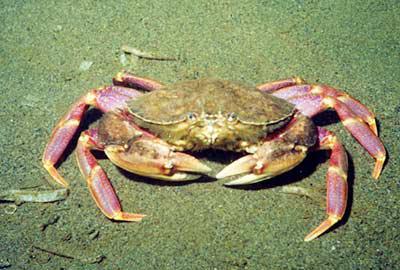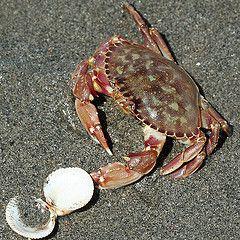The first image is the image on the left, the second image is the image on the right. Analyze the images presented: Is the assertion "Each image is a from-the-top view of one crab, but one image shows a crab with its face and front claws on the top, and one shows them at the bottom." valid? Answer yes or no. No. The first image is the image on the left, the second image is the image on the right. Evaluate the accuracy of this statement regarding the images: "Crabs are facing in opposite directions.". Is it true? Answer yes or no. No. 